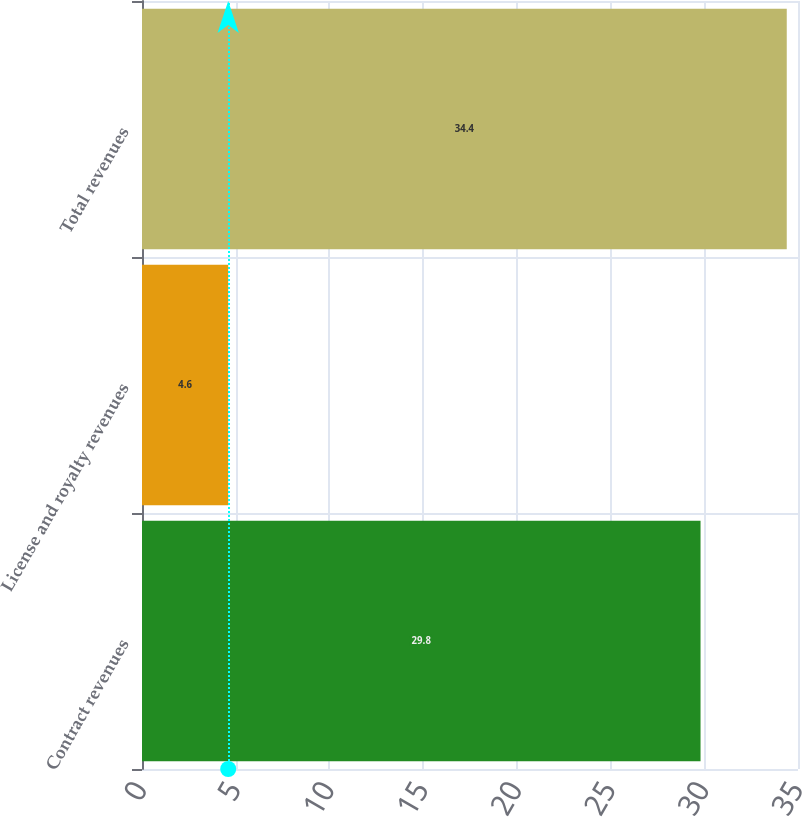<chart> <loc_0><loc_0><loc_500><loc_500><bar_chart><fcel>Contract revenues<fcel>License and royalty revenues<fcel>Total revenues<nl><fcel>29.8<fcel>4.6<fcel>34.4<nl></chart> 